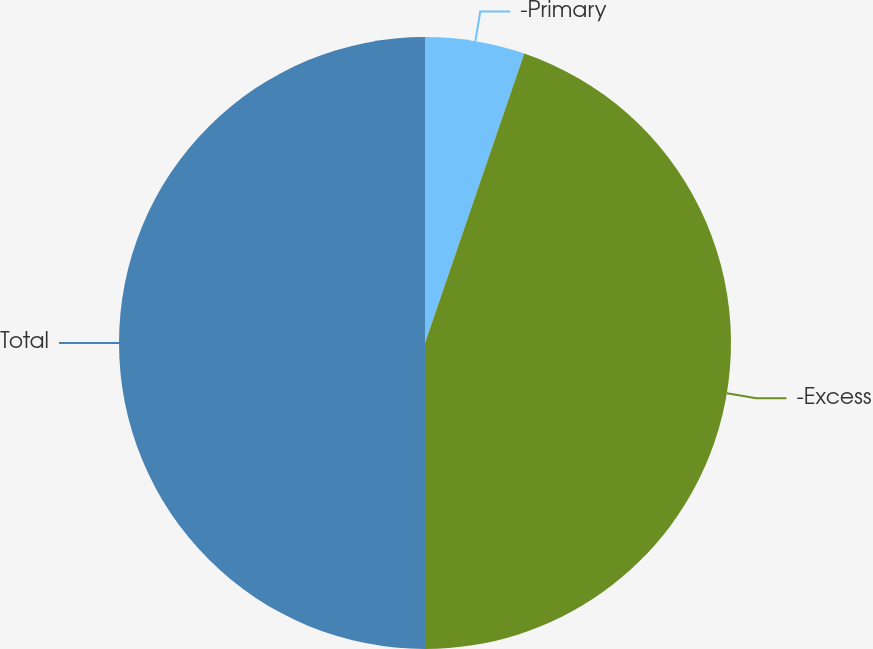Convert chart. <chart><loc_0><loc_0><loc_500><loc_500><pie_chart><fcel>-Primary<fcel>-Excess<fcel>Total<nl><fcel>5.26%<fcel>44.74%<fcel>50.0%<nl></chart> 